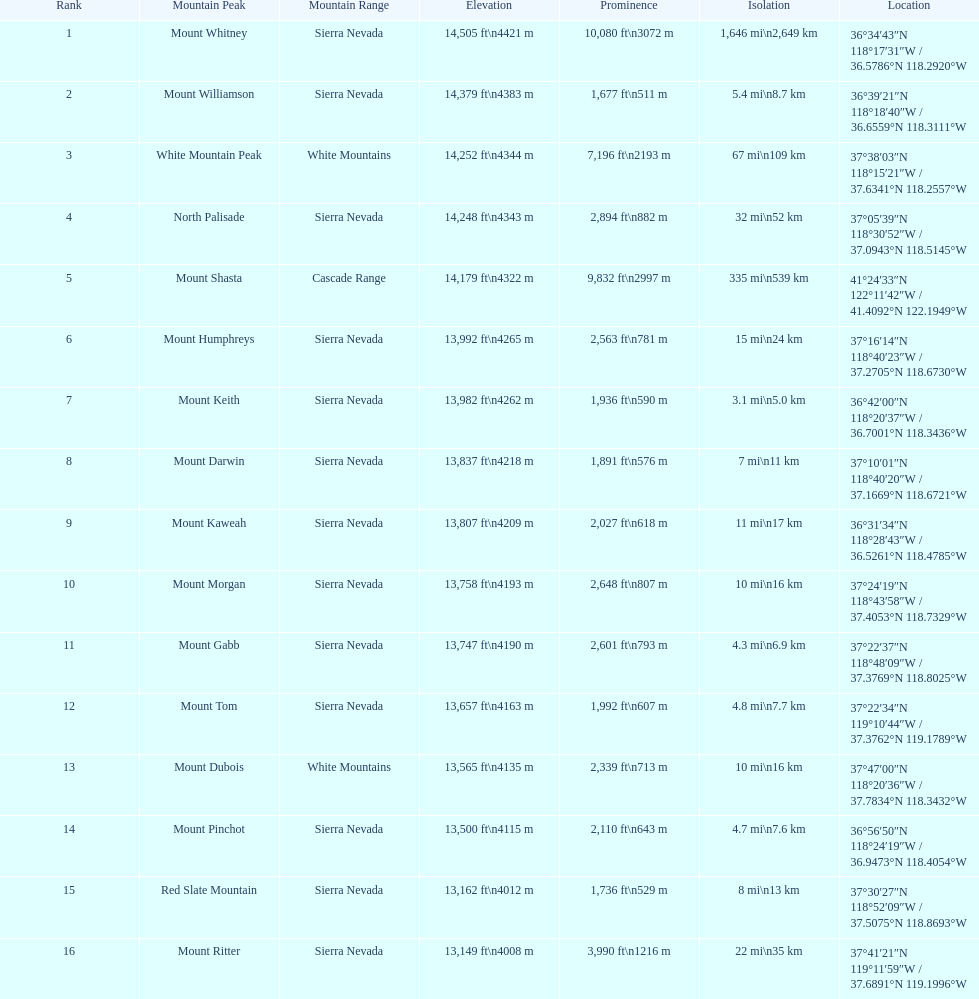On which mountain top can one find the greatest isolation? Mount Whitney. 